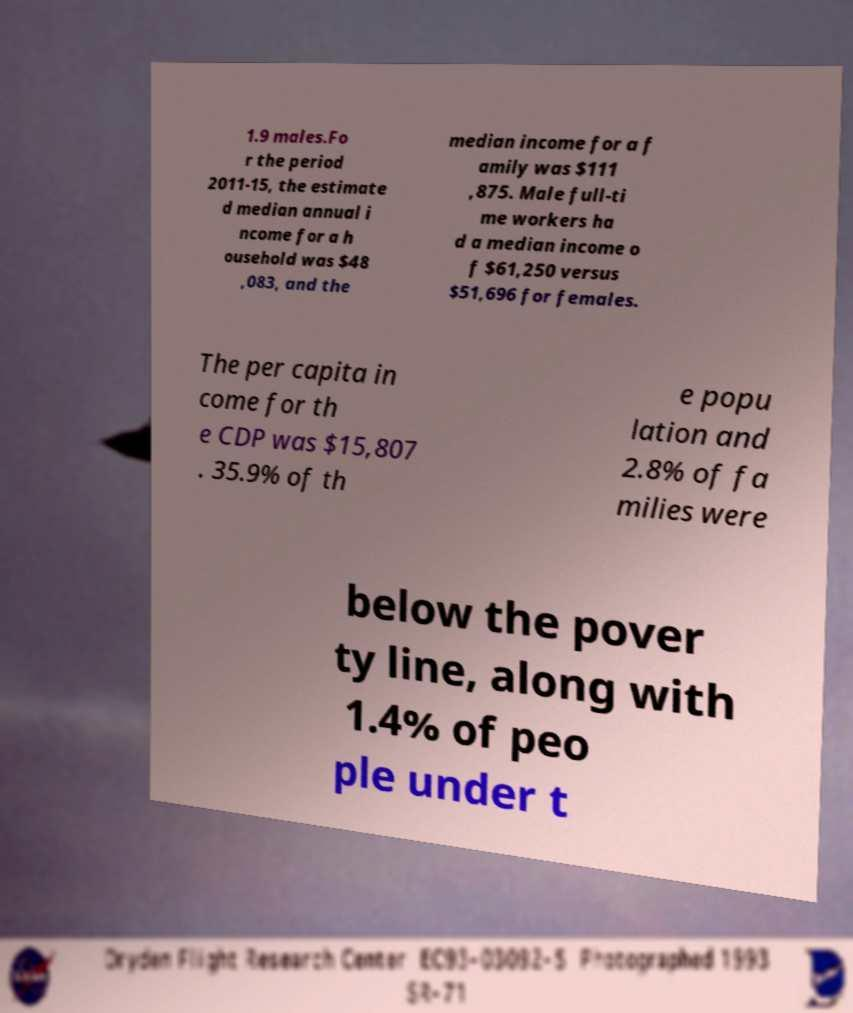Can you accurately transcribe the text from the provided image for me? 1.9 males.Fo r the period 2011-15, the estimate d median annual i ncome for a h ousehold was $48 ,083, and the median income for a f amily was $111 ,875. Male full-ti me workers ha d a median income o f $61,250 versus $51,696 for females. The per capita in come for th e CDP was $15,807 . 35.9% of th e popu lation and 2.8% of fa milies were below the pover ty line, along with 1.4% of peo ple under t 